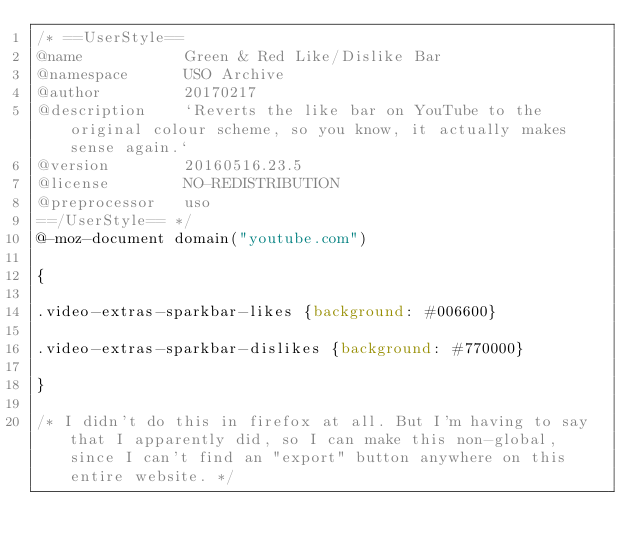<code> <loc_0><loc_0><loc_500><loc_500><_CSS_>/* ==UserStyle==
@name           Green & Red Like/Dislike Bar
@namespace      USO Archive
@author         20170217
@description    `Reverts the like bar on YouTube to the original colour scheme, so you know, it actually makes sense again.`
@version        20160516.23.5
@license        NO-REDISTRIBUTION
@preprocessor   uso
==/UserStyle== */
@-moz-document domain("youtube.com") 

{

.video-extras-sparkbar-likes {background: #006600}

.video-extras-sparkbar-dislikes {background: #770000}

}

/* I didn't do this in firefox at all. But I'm having to say that I apparently did, so I can make this non-global, since I can't find an "export" button anywhere on this entire website. */</code> 